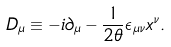Convert formula to latex. <formula><loc_0><loc_0><loc_500><loc_500>D _ { \mu } \equiv - i { \partial } _ { \mu } - \frac { 1 } { 2 \theta } { \epsilon } _ { { \mu } { \nu } } x ^ { \nu } .</formula> 